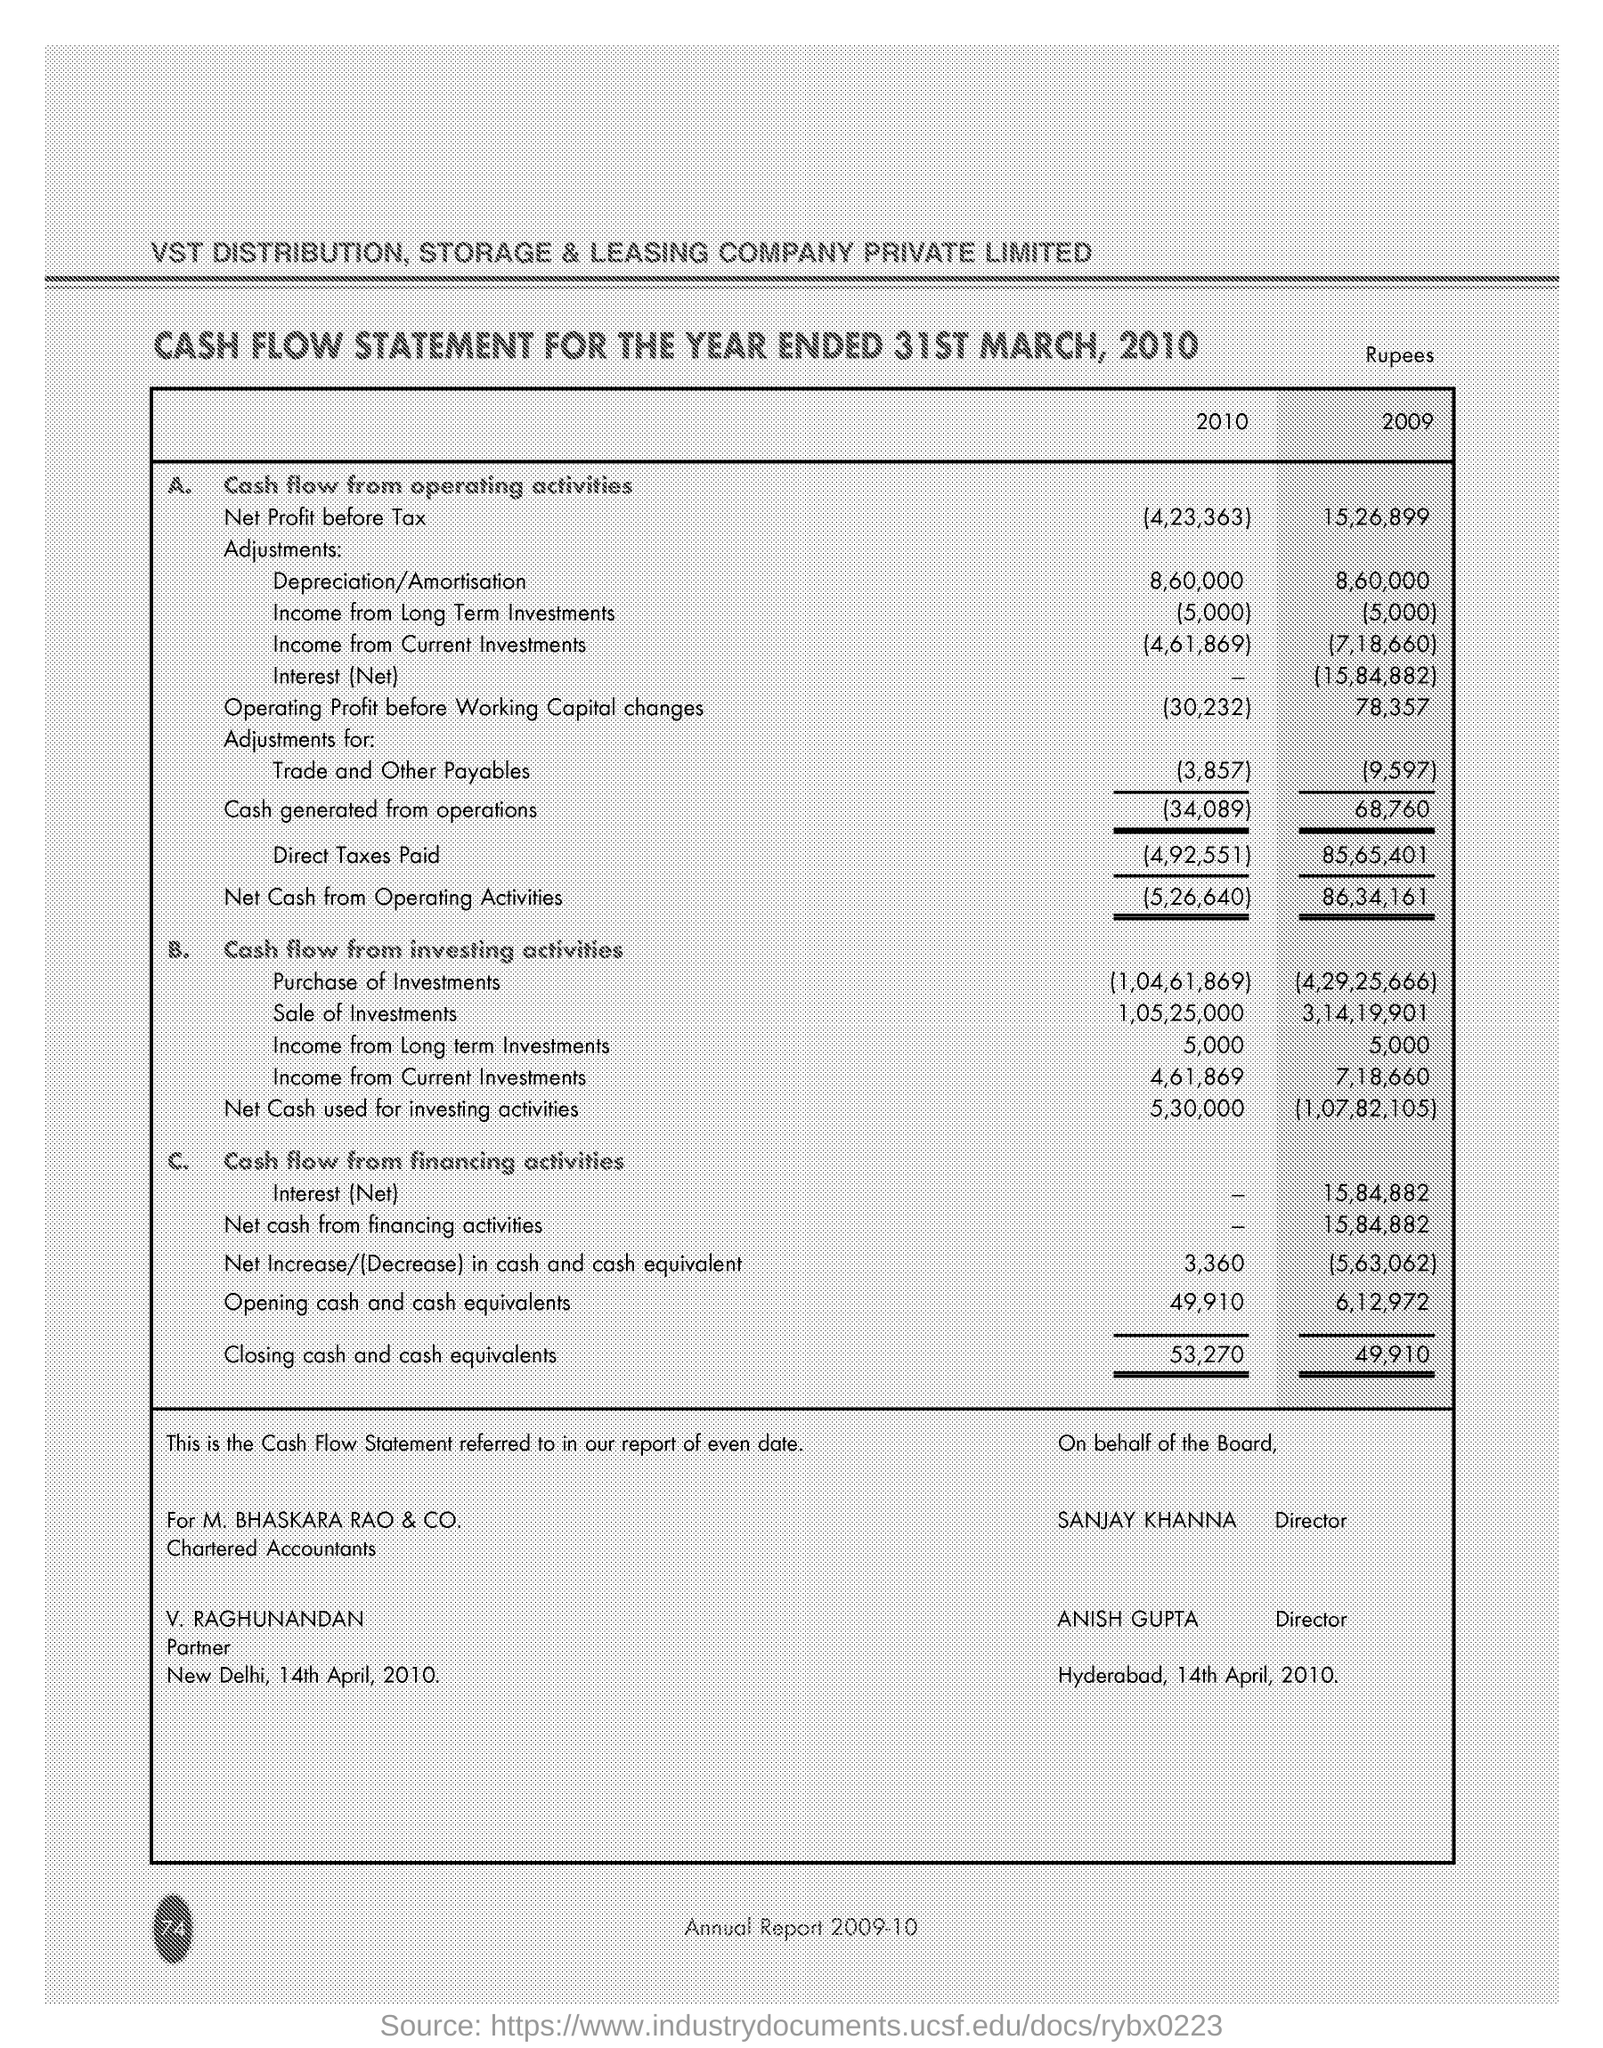What is the Company Name ?
Your answer should be very brief. STORAGE & LEASING COMPANY PRIVATE LIMITED. How much Net Profit before tax in 2010 ?
Ensure brevity in your answer.  4,23,363. How much sale of investments in 2009 ?
Provide a succinct answer. 3,14,19,901. How much Closing cash and cash equivalents in 2010 ?
Your answer should be very brief. 53,270. Who is the Partner ?
Ensure brevity in your answer.  V. RAGHUNANDAN. How much Direct Taxes paid in 2010 ?
Make the answer very short. (4,92,551). 